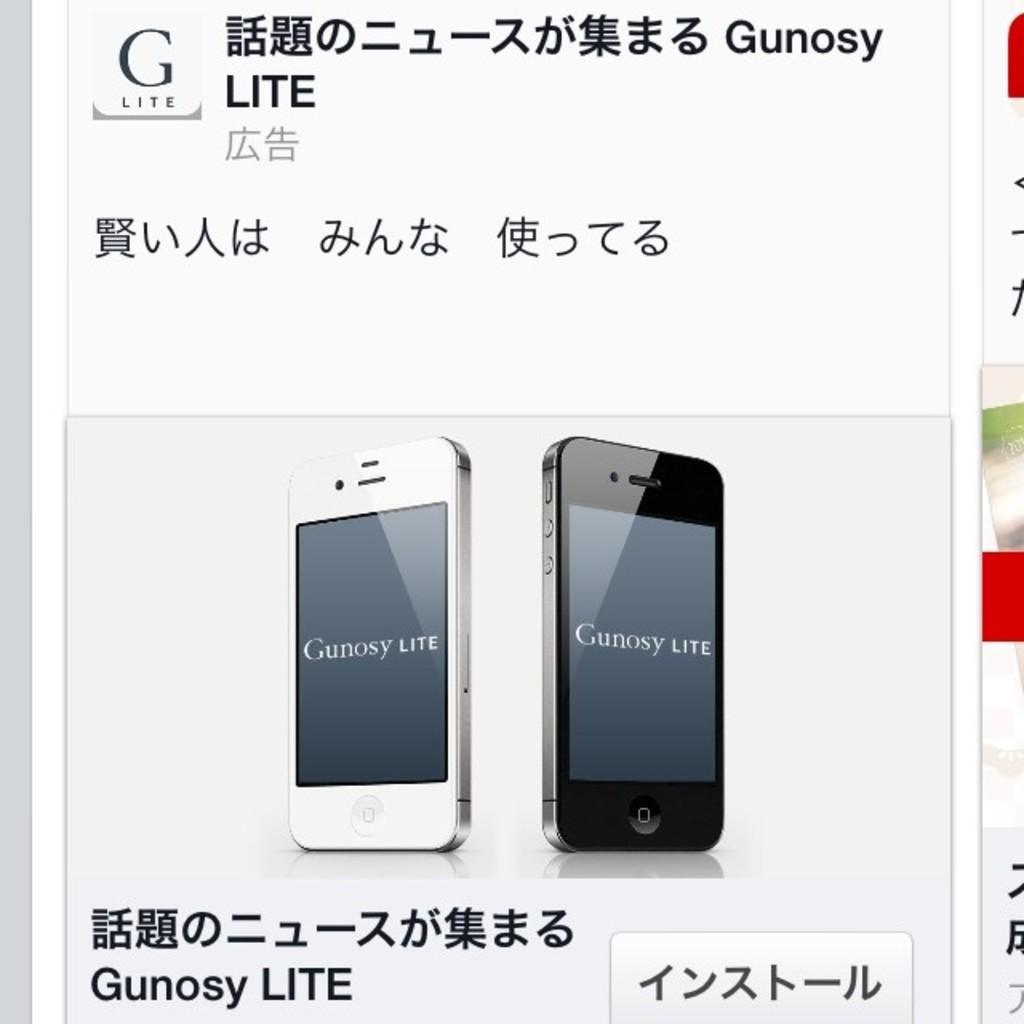<image>
Share a concise interpretation of the image provided. Two cell phones in an advertisement display the text Gunosy LITE. 